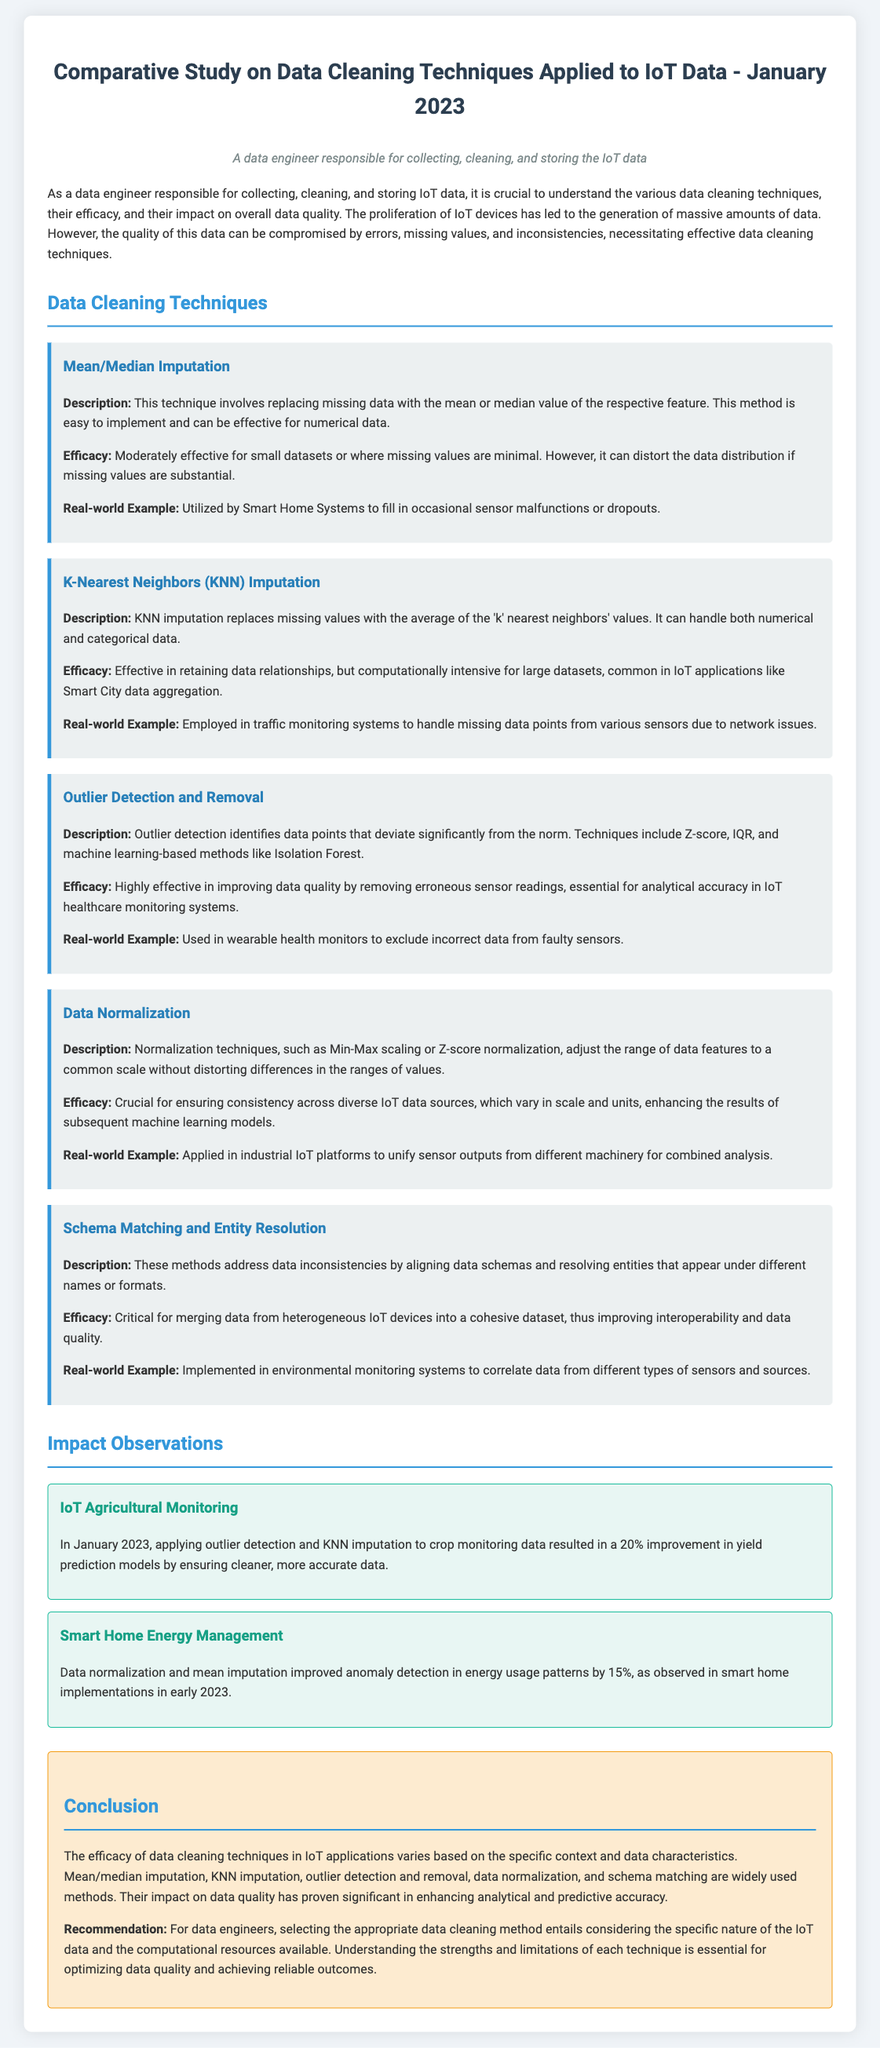What is the main focus of the study? The study focuses on the comparative efficacy of various data cleaning techniques applied to IoT data.
Answer: Comparative efficacy of data cleaning techniques What technique uses average of 'k' nearest neighbors? This technique is referred to as K-Nearest Neighbors (KNN) Imputation.
Answer: K-Nearest Neighbors (KNN) Imputation Which technique is crucial for ensuring consistency across diverse IoT data sources? Data normalization is the key technique to ensure consistency across diverse IoT data sources.
Answer: Data normalization What percentage improvement was observed in yield prediction models for IoT Agricultural Monitoring? The improvement observed was 20%.
Answer: 20% What is an example of real-world application for mean/median imputation? An example is its utilization in Smart Home Systems to fill in sensor malfunctions.
Answer: Smart Home Systems What impact did data normalization and mean imputation have on smart home energy management? The impact was a 15% improvement in anomaly detection in energy usage patterns.
Answer: 15% What is the overall conclusion about the efficacy of data cleaning techniques? The conclusion states that their efficacy varies based on specific context and data characteristics.
Answer: Efficacy varies based on context What is the recommendation for data engineers regarding data cleaning methods? The recommendation is to consider the specific nature of the IoT data and available computational resources.
Answer: Consider specific nature of IoT data and resources 